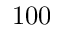Convert formula to latex. <formula><loc_0><loc_0><loc_500><loc_500>1 0 0</formula> 